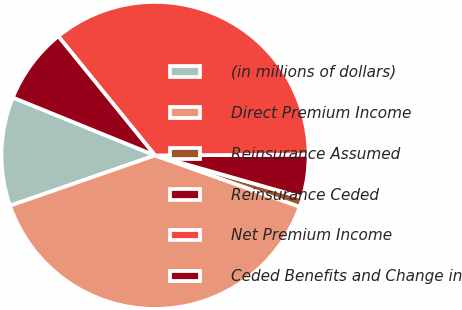Convert chart. <chart><loc_0><loc_0><loc_500><loc_500><pie_chart><fcel>(in millions of dollars)<fcel>Direct Premium Income<fcel>Reinsurance Assumed<fcel>Reinsurance Ceded<fcel>Net Premium Income<fcel>Ceded Benefits and Change in<nl><fcel>11.47%<fcel>39.26%<fcel>1.01%<fcel>4.5%<fcel>35.77%<fcel>7.99%<nl></chart> 